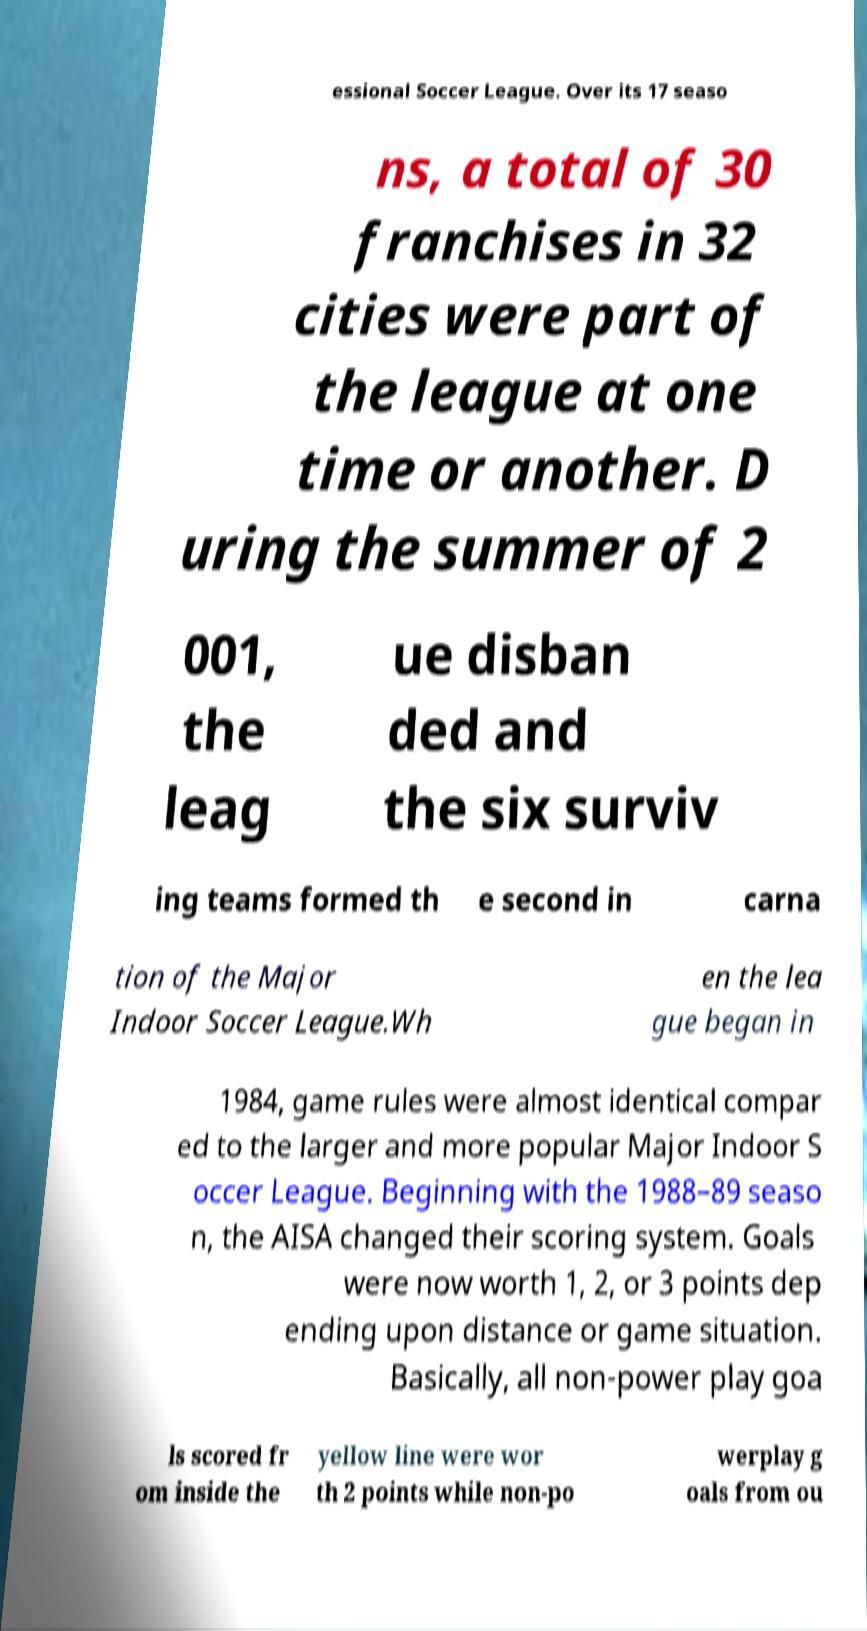There's text embedded in this image that I need extracted. Can you transcribe it verbatim? essional Soccer League. Over its 17 seaso ns, a total of 30 franchises in 32 cities were part of the league at one time or another. D uring the summer of 2 001, the leag ue disban ded and the six surviv ing teams formed th e second in carna tion of the Major Indoor Soccer League.Wh en the lea gue began in 1984, game rules were almost identical compar ed to the larger and more popular Major Indoor S occer League. Beginning with the 1988–89 seaso n, the AISA changed their scoring system. Goals were now worth 1, 2, or 3 points dep ending upon distance or game situation. Basically, all non-power play goa ls scored fr om inside the yellow line were wor th 2 points while non-po werplay g oals from ou 